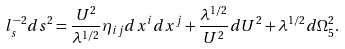<formula> <loc_0><loc_0><loc_500><loc_500>l _ { s } ^ { - 2 } d s ^ { 2 } = \frac { U ^ { 2 } } { \lambda ^ { 1 / 2 } } \eta _ { i j } d x ^ { i } d x ^ { j } + \frac { \lambda ^ { 1 / 2 } } { U ^ { 2 } } d U ^ { 2 } + \lambda ^ { 1 / 2 } d \Omega _ { 5 } ^ { 2 } .</formula> 